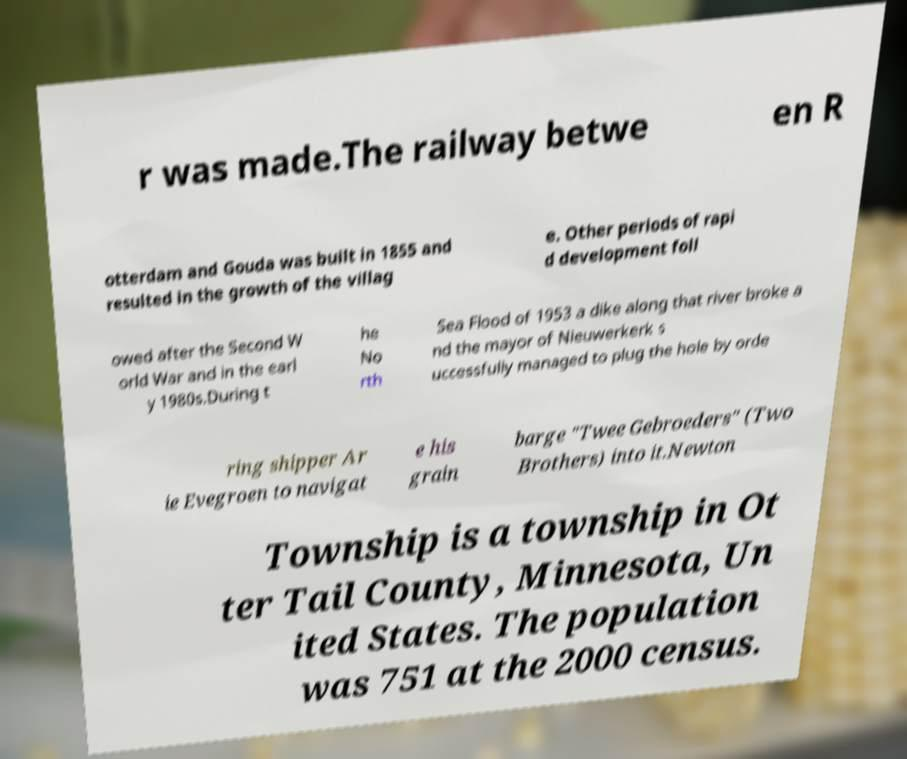Please read and relay the text visible in this image. What does it say? r was made.The railway betwe en R otterdam and Gouda was built in 1855 and resulted in the growth of the villag e. Other periods of rapi d development foll owed after the Second W orld War and in the earl y 1980s.During t he No rth Sea Flood of 1953 a dike along that river broke a nd the mayor of Nieuwerkerk s uccessfully managed to plug the hole by orde ring shipper Ar ie Evegroen to navigat e his grain barge "Twee Gebroeders" (Two Brothers) into it.Newton Township is a township in Ot ter Tail County, Minnesota, Un ited States. The population was 751 at the 2000 census. 